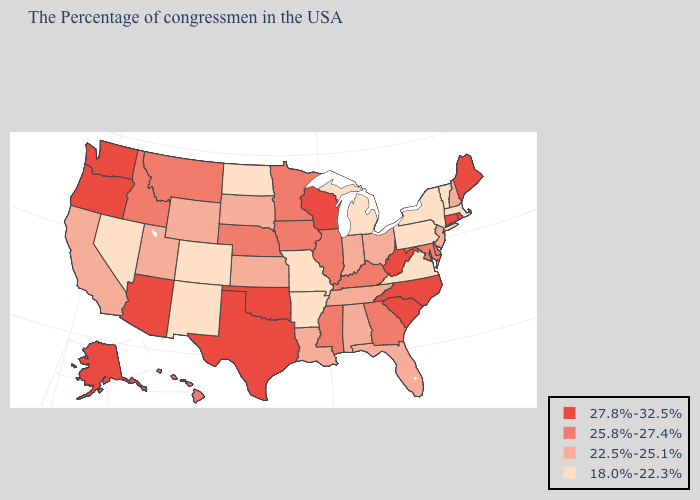Does Massachusetts have a lower value than Missouri?
Answer briefly. No. What is the lowest value in the USA?
Concise answer only. 18.0%-22.3%. What is the value of Wisconsin?
Short answer required. 27.8%-32.5%. What is the lowest value in states that border Texas?
Be succinct. 18.0%-22.3%. Does Wyoming have a lower value than Tennessee?
Give a very brief answer. No. Among the states that border Wyoming , does Colorado have the lowest value?
Quick response, please. Yes. What is the value of Mississippi?
Concise answer only. 25.8%-27.4%. Name the states that have a value in the range 25.8%-27.4%?
Concise answer only. Delaware, Maryland, Georgia, Kentucky, Illinois, Mississippi, Minnesota, Iowa, Nebraska, Montana, Idaho, Hawaii. Does the map have missing data?
Give a very brief answer. No. Name the states that have a value in the range 27.8%-32.5%?
Write a very short answer. Maine, Rhode Island, Connecticut, North Carolina, South Carolina, West Virginia, Wisconsin, Oklahoma, Texas, Arizona, Washington, Oregon, Alaska. Which states have the lowest value in the USA?
Write a very short answer. Massachusetts, Vermont, New York, Pennsylvania, Virginia, Michigan, Missouri, Arkansas, North Dakota, Colorado, New Mexico, Nevada. What is the highest value in states that border Iowa?
Quick response, please. 27.8%-32.5%. What is the value of Arizona?
Keep it brief. 27.8%-32.5%. What is the lowest value in states that border North Dakota?
Quick response, please. 22.5%-25.1%. Name the states that have a value in the range 18.0%-22.3%?
Short answer required. Massachusetts, Vermont, New York, Pennsylvania, Virginia, Michigan, Missouri, Arkansas, North Dakota, Colorado, New Mexico, Nevada. 